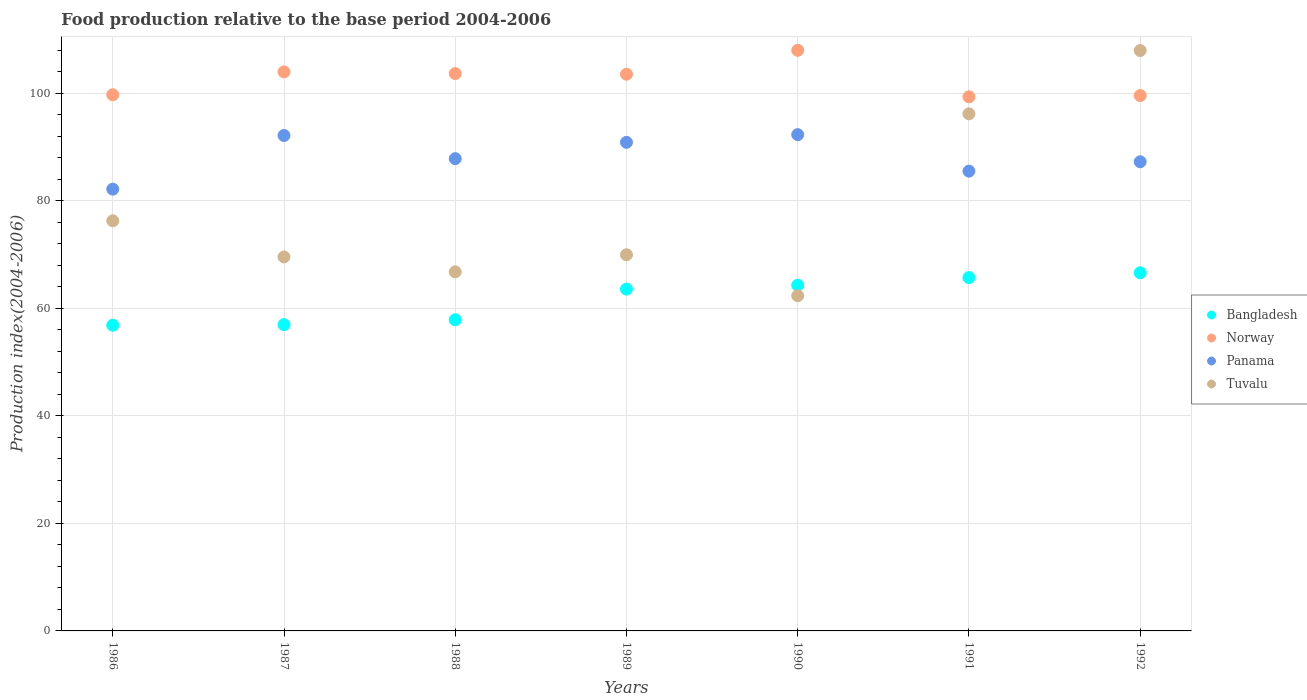How many different coloured dotlines are there?
Keep it short and to the point. 4. What is the food production index in Norway in 1992?
Make the answer very short. 99.54. Across all years, what is the maximum food production index in Tuvalu?
Your answer should be very brief. 107.91. Across all years, what is the minimum food production index in Panama?
Provide a succinct answer. 82.14. In which year was the food production index in Bangladesh minimum?
Offer a very short reply. 1986. What is the total food production index in Tuvalu in the graph?
Ensure brevity in your answer.  548.85. What is the difference between the food production index in Panama in 1988 and that in 1991?
Offer a very short reply. 2.32. What is the difference between the food production index in Panama in 1991 and the food production index in Norway in 1988?
Your answer should be very brief. -18.14. What is the average food production index in Bangladesh per year?
Ensure brevity in your answer.  61.68. In the year 1986, what is the difference between the food production index in Norway and food production index in Panama?
Your answer should be very brief. 17.55. What is the ratio of the food production index in Norway in 1990 to that in 1992?
Your answer should be compact. 1.08. What is the difference between the highest and the second highest food production index in Norway?
Provide a succinct answer. 4.01. What is the difference between the highest and the lowest food production index in Bangladesh?
Offer a very short reply. 9.75. In how many years, is the food production index in Panama greater than the average food production index in Panama taken over all years?
Offer a terse response. 3. Is the sum of the food production index in Bangladesh in 1987 and 1992 greater than the maximum food production index in Panama across all years?
Ensure brevity in your answer.  Yes. Is it the case that in every year, the sum of the food production index in Tuvalu and food production index in Panama  is greater than the sum of food production index in Norway and food production index in Bangladesh?
Keep it short and to the point. No. Is it the case that in every year, the sum of the food production index in Bangladesh and food production index in Norway  is greater than the food production index in Panama?
Provide a succinct answer. Yes. Is the food production index in Panama strictly greater than the food production index in Bangladesh over the years?
Provide a short and direct response. Yes. Is the food production index in Panama strictly less than the food production index in Tuvalu over the years?
Keep it short and to the point. No. How many dotlines are there?
Your answer should be very brief. 4. How many years are there in the graph?
Offer a very short reply. 7. Are the values on the major ticks of Y-axis written in scientific E-notation?
Your response must be concise. No. Does the graph contain grids?
Your response must be concise. Yes. Where does the legend appear in the graph?
Your answer should be very brief. Center right. How many legend labels are there?
Provide a succinct answer. 4. What is the title of the graph?
Offer a very short reply. Food production relative to the base period 2004-2006. What is the label or title of the X-axis?
Provide a succinct answer. Years. What is the label or title of the Y-axis?
Your answer should be very brief. Production index(2004-2006). What is the Production index(2004-2006) of Bangladesh in 1986?
Your answer should be compact. 56.84. What is the Production index(2004-2006) of Norway in 1986?
Offer a very short reply. 99.69. What is the Production index(2004-2006) of Panama in 1986?
Your answer should be compact. 82.14. What is the Production index(2004-2006) of Tuvalu in 1986?
Provide a succinct answer. 76.25. What is the Production index(2004-2006) of Bangladesh in 1987?
Your response must be concise. 56.95. What is the Production index(2004-2006) of Norway in 1987?
Keep it short and to the point. 103.94. What is the Production index(2004-2006) of Panama in 1987?
Provide a succinct answer. 92.11. What is the Production index(2004-2006) in Tuvalu in 1987?
Provide a short and direct response. 69.53. What is the Production index(2004-2006) of Bangladesh in 1988?
Offer a terse response. 57.85. What is the Production index(2004-2006) of Norway in 1988?
Give a very brief answer. 103.63. What is the Production index(2004-2006) of Panama in 1988?
Make the answer very short. 87.81. What is the Production index(2004-2006) in Tuvalu in 1988?
Offer a very short reply. 66.76. What is the Production index(2004-2006) of Bangladesh in 1989?
Make the answer very short. 63.55. What is the Production index(2004-2006) in Norway in 1989?
Offer a very short reply. 103.51. What is the Production index(2004-2006) in Panama in 1989?
Provide a succinct answer. 90.84. What is the Production index(2004-2006) of Tuvalu in 1989?
Your response must be concise. 69.94. What is the Production index(2004-2006) of Bangladesh in 1990?
Offer a very short reply. 64.28. What is the Production index(2004-2006) in Norway in 1990?
Provide a short and direct response. 107.95. What is the Production index(2004-2006) of Panama in 1990?
Ensure brevity in your answer.  92.27. What is the Production index(2004-2006) in Tuvalu in 1990?
Your answer should be compact. 62.32. What is the Production index(2004-2006) of Bangladesh in 1991?
Keep it short and to the point. 65.69. What is the Production index(2004-2006) in Norway in 1991?
Offer a very short reply. 99.31. What is the Production index(2004-2006) of Panama in 1991?
Offer a very short reply. 85.49. What is the Production index(2004-2006) of Tuvalu in 1991?
Your answer should be compact. 96.14. What is the Production index(2004-2006) in Bangladesh in 1992?
Your answer should be compact. 66.59. What is the Production index(2004-2006) in Norway in 1992?
Offer a very short reply. 99.54. What is the Production index(2004-2006) in Panama in 1992?
Provide a succinct answer. 87.23. What is the Production index(2004-2006) of Tuvalu in 1992?
Provide a succinct answer. 107.91. Across all years, what is the maximum Production index(2004-2006) of Bangladesh?
Make the answer very short. 66.59. Across all years, what is the maximum Production index(2004-2006) of Norway?
Make the answer very short. 107.95. Across all years, what is the maximum Production index(2004-2006) in Panama?
Provide a succinct answer. 92.27. Across all years, what is the maximum Production index(2004-2006) of Tuvalu?
Offer a very short reply. 107.91. Across all years, what is the minimum Production index(2004-2006) of Bangladesh?
Your response must be concise. 56.84. Across all years, what is the minimum Production index(2004-2006) of Norway?
Your answer should be compact. 99.31. Across all years, what is the minimum Production index(2004-2006) in Panama?
Ensure brevity in your answer.  82.14. Across all years, what is the minimum Production index(2004-2006) in Tuvalu?
Provide a succinct answer. 62.32. What is the total Production index(2004-2006) in Bangladesh in the graph?
Your answer should be compact. 431.75. What is the total Production index(2004-2006) in Norway in the graph?
Ensure brevity in your answer.  717.57. What is the total Production index(2004-2006) of Panama in the graph?
Offer a terse response. 617.89. What is the total Production index(2004-2006) of Tuvalu in the graph?
Provide a short and direct response. 548.85. What is the difference between the Production index(2004-2006) of Bangladesh in 1986 and that in 1987?
Offer a very short reply. -0.11. What is the difference between the Production index(2004-2006) of Norway in 1986 and that in 1987?
Make the answer very short. -4.25. What is the difference between the Production index(2004-2006) in Panama in 1986 and that in 1987?
Your answer should be compact. -9.97. What is the difference between the Production index(2004-2006) of Tuvalu in 1986 and that in 1987?
Keep it short and to the point. 6.72. What is the difference between the Production index(2004-2006) of Bangladesh in 1986 and that in 1988?
Offer a very short reply. -1.01. What is the difference between the Production index(2004-2006) in Norway in 1986 and that in 1988?
Your response must be concise. -3.94. What is the difference between the Production index(2004-2006) in Panama in 1986 and that in 1988?
Ensure brevity in your answer.  -5.67. What is the difference between the Production index(2004-2006) of Tuvalu in 1986 and that in 1988?
Provide a short and direct response. 9.49. What is the difference between the Production index(2004-2006) of Bangladesh in 1986 and that in 1989?
Your response must be concise. -6.71. What is the difference between the Production index(2004-2006) in Norway in 1986 and that in 1989?
Give a very brief answer. -3.82. What is the difference between the Production index(2004-2006) in Panama in 1986 and that in 1989?
Give a very brief answer. -8.7. What is the difference between the Production index(2004-2006) in Tuvalu in 1986 and that in 1989?
Your answer should be compact. 6.31. What is the difference between the Production index(2004-2006) in Bangladesh in 1986 and that in 1990?
Your answer should be compact. -7.44. What is the difference between the Production index(2004-2006) of Norway in 1986 and that in 1990?
Give a very brief answer. -8.26. What is the difference between the Production index(2004-2006) in Panama in 1986 and that in 1990?
Ensure brevity in your answer.  -10.13. What is the difference between the Production index(2004-2006) of Tuvalu in 1986 and that in 1990?
Your response must be concise. 13.93. What is the difference between the Production index(2004-2006) of Bangladesh in 1986 and that in 1991?
Give a very brief answer. -8.85. What is the difference between the Production index(2004-2006) in Norway in 1986 and that in 1991?
Offer a terse response. 0.38. What is the difference between the Production index(2004-2006) in Panama in 1986 and that in 1991?
Your answer should be very brief. -3.35. What is the difference between the Production index(2004-2006) of Tuvalu in 1986 and that in 1991?
Offer a very short reply. -19.89. What is the difference between the Production index(2004-2006) in Bangladesh in 1986 and that in 1992?
Provide a short and direct response. -9.75. What is the difference between the Production index(2004-2006) in Panama in 1986 and that in 1992?
Offer a terse response. -5.09. What is the difference between the Production index(2004-2006) in Tuvalu in 1986 and that in 1992?
Provide a short and direct response. -31.66. What is the difference between the Production index(2004-2006) in Norway in 1987 and that in 1988?
Give a very brief answer. 0.31. What is the difference between the Production index(2004-2006) in Tuvalu in 1987 and that in 1988?
Offer a very short reply. 2.77. What is the difference between the Production index(2004-2006) of Bangladesh in 1987 and that in 1989?
Make the answer very short. -6.6. What is the difference between the Production index(2004-2006) of Norway in 1987 and that in 1989?
Keep it short and to the point. 0.43. What is the difference between the Production index(2004-2006) in Panama in 1987 and that in 1989?
Keep it short and to the point. 1.27. What is the difference between the Production index(2004-2006) in Tuvalu in 1987 and that in 1989?
Offer a terse response. -0.41. What is the difference between the Production index(2004-2006) of Bangladesh in 1987 and that in 1990?
Provide a succinct answer. -7.33. What is the difference between the Production index(2004-2006) of Norway in 1987 and that in 1990?
Your answer should be compact. -4.01. What is the difference between the Production index(2004-2006) in Panama in 1987 and that in 1990?
Provide a succinct answer. -0.16. What is the difference between the Production index(2004-2006) of Tuvalu in 1987 and that in 1990?
Provide a succinct answer. 7.21. What is the difference between the Production index(2004-2006) of Bangladesh in 1987 and that in 1991?
Give a very brief answer. -8.74. What is the difference between the Production index(2004-2006) in Norway in 1987 and that in 1991?
Keep it short and to the point. 4.63. What is the difference between the Production index(2004-2006) in Panama in 1987 and that in 1991?
Your response must be concise. 6.62. What is the difference between the Production index(2004-2006) in Tuvalu in 1987 and that in 1991?
Offer a very short reply. -26.61. What is the difference between the Production index(2004-2006) in Bangladesh in 1987 and that in 1992?
Your answer should be very brief. -9.64. What is the difference between the Production index(2004-2006) in Panama in 1987 and that in 1992?
Your answer should be compact. 4.88. What is the difference between the Production index(2004-2006) of Tuvalu in 1987 and that in 1992?
Give a very brief answer. -38.38. What is the difference between the Production index(2004-2006) of Norway in 1988 and that in 1989?
Make the answer very short. 0.12. What is the difference between the Production index(2004-2006) in Panama in 1988 and that in 1989?
Offer a very short reply. -3.03. What is the difference between the Production index(2004-2006) of Tuvalu in 1988 and that in 1989?
Offer a very short reply. -3.18. What is the difference between the Production index(2004-2006) of Bangladesh in 1988 and that in 1990?
Your response must be concise. -6.43. What is the difference between the Production index(2004-2006) in Norway in 1988 and that in 1990?
Your answer should be compact. -4.32. What is the difference between the Production index(2004-2006) of Panama in 1988 and that in 1990?
Keep it short and to the point. -4.46. What is the difference between the Production index(2004-2006) of Tuvalu in 1988 and that in 1990?
Ensure brevity in your answer.  4.44. What is the difference between the Production index(2004-2006) in Bangladesh in 1988 and that in 1991?
Keep it short and to the point. -7.84. What is the difference between the Production index(2004-2006) of Norway in 1988 and that in 1991?
Ensure brevity in your answer.  4.32. What is the difference between the Production index(2004-2006) in Panama in 1988 and that in 1991?
Your response must be concise. 2.32. What is the difference between the Production index(2004-2006) in Tuvalu in 1988 and that in 1991?
Make the answer very short. -29.38. What is the difference between the Production index(2004-2006) in Bangladesh in 1988 and that in 1992?
Keep it short and to the point. -8.74. What is the difference between the Production index(2004-2006) of Norway in 1988 and that in 1992?
Ensure brevity in your answer.  4.09. What is the difference between the Production index(2004-2006) of Panama in 1988 and that in 1992?
Keep it short and to the point. 0.58. What is the difference between the Production index(2004-2006) of Tuvalu in 1988 and that in 1992?
Provide a succinct answer. -41.15. What is the difference between the Production index(2004-2006) in Bangladesh in 1989 and that in 1990?
Provide a succinct answer. -0.73. What is the difference between the Production index(2004-2006) of Norway in 1989 and that in 1990?
Provide a short and direct response. -4.44. What is the difference between the Production index(2004-2006) in Panama in 1989 and that in 1990?
Your answer should be compact. -1.43. What is the difference between the Production index(2004-2006) of Tuvalu in 1989 and that in 1990?
Your answer should be compact. 7.62. What is the difference between the Production index(2004-2006) in Bangladesh in 1989 and that in 1991?
Keep it short and to the point. -2.14. What is the difference between the Production index(2004-2006) in Panama in 1989 and that in 1991?
Your response must be concise. 5.35. What is the difference between the Production index(2004-2006) of Tuvalu in 1989 and that in 1991?
Your answer should be compact. -26.2. What is the difference between the Production index(2004-2006) in Bangladesh in 1989 and that in 1992?
Provide a short and direct response. -3.04. What is the difference between the Production index(2004-2006) of Norway in 1989 and that in 1992?
Make the answer very short. 3.97. What is the difference between the Production index(2004-2006) in Panama in 1989 and that in 1992?
Offer a terse response. 3.61. What is the difference between the Production index(2004-2006) in Tuvalu in 1989 and that in 1992?
Ensure brevity in your answer.  -37.97. What is the difference between the Production index(2004-2006) of Bangladesh in 1990 and that in 1991?
Offer a very short reply. -1.41. What is the difference between the Production index(2004-2006) in Norway in 1990 and that in 1991?
Your response must be concise. 8.64. What is the difference between the Production index(2004-2006) in Panama in 1990 and that in 1991?
Your answer should be very brief. 6.78. What is the difference between the Production index(2004-2006) in Tuvalu in 1990 and that in 1991?
Provide a short and direct response. -33.82. What is the difference between the Production index(2004-2006) in Bangladesh in 1990 and that in 1992?
Your response must be concise. -2.31. What is the difference between the Production index(2004-2006) in Norway in 1990 and that in 1992?
Provide a succinct answer. 8.41. What is the difference between the Production index(2004-2006) of Panama in 1990 and that in 1992?
Ensure brevity in your answer.  5.04. What is the difference between the Production index(2004-2006) in Tuvalu in 1990 and that in 1992?
Ensure brevity in your answer.  -45.59. What is the difference between the Production index(2004-2006) in Bangladesh in 1991 and that in 1992?
Your answer should be very brief. -0.9. What is the difference between the Production index(2004-2006) of Norway in 1991 and that in 1992?
Provide a succinct answer. -0.23. What is the difference between the Production index(2004-2006) of Panama in 1991 and that in 1992?
Make the answer very short. -1.74. What is the difference between the Production index(2004-2006) in Tuvalu in 1991 and that in 1992?
Offer a terse response. -11.77. What is the difference between the Production index(2004-2006) of Bangladesh in 1986 and the Production index(2004-2006) of Norway in 1987?
Your answer should be compact. -47.1. What is the difference between the Production index(2004-2006) in Bangladesh in 1986 and the Production index(2004-2006) in Panama in 1987?
Offer a very short reply. -35.27. What is the difference between the Production index(2004-2006) of Bangladesh in 1986 and the Production index(2004-2006) of Tuvalu in 1987?
Your answer should be very brief. -12.69. What is the difference between the Production index(2004-2006) in Norway in 1986 and the Production index(2004-2006) in Panama in 1987?
Your answer should be compact. 7.58. What is the difference between the Production index(2004-2006) of Norway in 1986 and the Production index(2004-2006) of Tuvalu in 1987?
Give a very brief answer. 30.16. What is the difference between the Production index(2004-2006) of Panama in 1986 and the Production index(2004-2006) of Tuvalu in 1987?
Provide a short and direct response. 12.61. What is the difference between the Production index(2004-2006) of Bangladesh in 1986 and the Production index(2004-2006) of Norway in 1988?
Keep it short and to the point. -46.79. What is the difference between the Production index(2004-2006) of Bangladesh in 1986 and the Production index(2004-2006) of Panama in 1988?
Your response must be concise. -30.97. What is the difference between the Production index(2004-2006) of Bangladesh in 1986 and the Production index(2004-2006) of Tuvalu in 1988?
Make the answer very short. -9.92. What is the difference between the Production index(2004-2006) in Norway in 1986 and the Production index(2004-2006) in Panama in 1988?
Ensure brevity in your answer.  11.88. What is the difference between the Production index(2004-2006) in Norway in 1986 and the Production index(2004-2006) in Tuvalu in 1988?
Your response must be concise. 32.93. What is the difference between the Production index(2004-2006) in Panama in 1986 and the Production index(2004-2006) in Tuvalu in 1988?
Offer a terse response. 15.38. What is the difference between the Production index(2004-2006) of Bangladesh in 1986 and the Production index(2004-2006) of Norway in 1989?
Give a very brief answer. -46.67. What is the difference between the Production index(2004-2006) in Bangladesh in 1986 and the Production index(2004-2006) in Panama in 1989?
Ensure brevity in your answer.  -34. What is the difference between the Production index(2004-2006) of Bangladesh in 1986 and the Production index(2004-2006) of Tuvalu in 1989?
Offer a terse response. -13.1. What is the difference between the Production index(2004-2006) in Norway in 1986 and the Production index(2004-2006) in Panama in 1989?
Make the answer very short. 8.85. What is the difference between the Production index(2004-2006) of Norway in 1986 and the Production index(2004-2006) of Tuvalu in 1989?
Your answer should be very brief. 29.75. What is the difference between the Production index(2004-2006) in Bangladesh in 1986 and the Production index(2004-2006) in Norway in 1990?
Your answer should be compact. -51.11. What is the difference between the Production index(2004-2006) of Bangladesh in 1986 and the Production index(2004-2006) of Panama in 1990?
Give a very brief answer. -35.43. What is the difference between the Production index(2004-2006) of Bangladesh in 1986 and the Production index(2004-2006) of Tuvalu in 1990?
Keep it short and to the point. -5.48. What is the difference between the Production index(2004-2006) of Norway in 1986 and the Production index(2004-2006) of Panama in 1990?
Offer a terse response. 7.42. What is the difference between the Production index(2004-2006) of Norway in 1986 and the Production index(2004-2006) of Tuvalu in 1990?
Make the answer very short. 37.37. What is the difference between the Production index(2004-2006) in Panama in 1986 and the Production index(2004-2006) in Tuvalu in 1990?
Give a very brief answer. 19.82. What is the difference between the Production index(2004-2006) in Bangladesh in 1986 and the Production index(2004-2006) in Norway in 1991?
Make the answer very short. -42.47. What is the difference between the Production index(2004-2006) of Bangladesh in 1986 and the Production index(2004-2006) of Panama in 1991?
Ensure brevity in your answer.  -28.65. What is the difference between the Production index(2004-2006) in Bangladesh in 1986 and the Production index(2004-2006) in Tuvalu in 1991?
Your answer should be compact. -39.3. What is the difference between the Production index(2004-2006) in Norway in 1986 and the Production index(2004-2006) in Tuvalu in 1991?
Provide a succinct answer. 3.55. What is the difference between the Production index(2004-2006) of Bangladesh in 1986 and the Production index(2004-2006) of Norway in 1992?
Give a very brief answer. -42.7. What is the difference between the Production index(2004-2006) in Bangladesh in 1986 and the Production index(2004-2006) in Panama in 1992?
Provide a short and direct response. -30.39. What is the difference between the Production index(2004-2006) in Bangladesh in 1986 and the Production index(2004-2006) in Tuvalu in 1992?
Provide a succinct answer. -51.07. What is the difference between the Production index(2004-2006) of Norway in 1986 and the Production index(2004-2006) of Panama in 1992?
Offer a terse response. 12.46. What is the difference between the Production index(2004-2006) in Norway in 1986 and the Production index(2004-2006) in Tuvalu in 1992?
Ensure brevity in your answer.  -8.22. What is the difference between the Production index(2004-2006) in Panama in 1986 and the Production index(2004-2006) in Tuvalu in 1992?
Keep it short and to the point. -25.77. What is the difference between the Production index(2004-2006) in Bangladesh in 1987 and the Production index(2004-2006) in Norway in 1988?
Offer a very short reply. -46.68. What is the difference between the Production index(2004-2006) of Bangladesh in 1987 and the Production index(2004-2006) of Panama in 1988?
Give a very brief answer. -30.86. What is the difference between the Production index(2004-2006) in Bangladesh in 1987 and the Production index(2004-2006) in Tuvalu in 1988?
Keep it short and to the point. -9.81. What is the difference between the Production index(2004-2006) in Norway in 1987 and the Production index(2004-2006) in Panama in 1988?
Offer a very short reply. 16.13. What is the difference between the Production index(2004-2006) of Norway in 1987 and the Production index(2004-2006) of Tuvalu in 1988?
Your answer should be very brief. 37.18. What is the difference between the Production index(2004-2006) of Panama in 1987 and the Production index(2004-2006) of Tuvalu in 1988?
Provide a short and direct response. 25.35. What is the difference between the Production index(2004-2006) of Bangladesh in 1987 and the Production index(2004-2006) of Norway in 1989?
Offer a terse response. -46.56. What is the difference between the Production index(2004-2006) in Bangladesh in 1987 and the Production index(2004-2006) in Panama in 1989?
Offer a very short reply. -33.89. What is the difference between the Production index(2004-2006) of Bangladesh in 1987 and the Production index(2004-2006) of Tuvalu in 1989?
Make the answer very short. -12.99. What is the difference between the Production index(2004-2006) in Norway in 1987 and the Production index(2004-2006) in Tuvalu in 1989?
Keep it short and to the point. 34. What is the difference between the Production index(2004-2006) in Panama in 1987 and the Production index(2004-2006) in Tuvalu in 1989?
Give a very brief answer. 22.17. What is the difference between the Production index(2004-2006) in Bangladesh in 1987 and the Production index(2004-2006) in Norway in 1990?
Keep it short and to the point. -51. What is the difference between the Production index(2004-2006) of Bangladesh in 1987 and the Production index(2004-2006) of Panama in 1990?
Give a very brief answer. -35.32. What is the difference between the Production index(2004-2006) of Bangladesh in 1987 and the Production index(2004-2006) of Tuvalu in 1990?
Keep it short and to the point. -5.37. What is the difference between the Production index(2004-2006) in Norway in 1987 and the Production index(2004-2006) in Panama in 1990?
Provide a succinct answer. 11.67. What is the difference between the Production index(2004-2006) of Norway in 1987 and the Production index(2004-2006) of Tuvalu in 1990?
Your response must be concise. 41.62. What is the difference between the Production index(2004-2006) of Panama in 1987 and the Production index(2004-2006) of Tuvalu in 1990?
Keep it short and to the point. 29.79. What is the difference between the Production index(2004-2006) of Bangladesh in 1987 and the Production index(2004-2006) of Norway in 1991?
Ensure brevity in your answer.  -42.36. What is the difference between the Production index(2004-2006) in Bangladesh in 1987 and the Production index(2004-2006) in Panama in 1991?
Your response must be concise. -28.54. What is the difference between the Production index(2004-2006) in Bangladesh in 1987 and the Production index(2004-2006) in Tuvalu in 1991?
Your answer should be very brief. -39.19. What is the difference between the Production index(2004-2006) of Norway in 1987 and the Production index(2004-2006) of Panama in 1991?
Your response must be concise. 18.45. What is the difference between the Production index(2004-2006) of Norway in 1987 and the Production index(2004-2006) of Tuvalu in 1991?
Your answer should be compact. 7.8. What is the difference between the Production index(2004-2006) in Panama in 1987 and the Production index(2004-2006) in Tuvalu in 1991?
Provide a succinct answer. -4.03. What is the difference between the Production index(2004-2006) in Bangladesh in 1987 and the Production index(2004-2006) in Norway in 1992?
Your answer should be very brief. -42.59. What is the difference between the Production index(2004-2006) of Bangladesh in 1987 and the Production index(2004-2006) of Panama in 1992?
Your answer should be compact. -30.28. What is the difference between the Production index(2004-2006) in Bangladesh in 1987 and the Production index(2004-2006) in Tuvalu in 1992?
Ensure brevity in your answer.  -50.96. What is the difference between the Production index(2004-2006) of Norway in 1987 and the Production index(2004-2006) of Panama in 1992?
Provide a short and direct response. 16.71. What is the difference between the Production index(2004-2006) in Norway in 1987 and the Production index(2004-2006) in Tuvalu in 1992?
Your answer should be very brief. -3.97. What is the difference between the Production index(2004-2006) in Panama in 1987 and the Production index(2004-2006) in Tuvalu in 1992?
Provide a succinct answer. -15.8. What is the difference between the Production index(2004-2006) of Bangladesh in 1988 and the Production index(2004-2006) of Norway in 1989?
Ensure brevity in your answer.  -45.66. What is the difference between the Production index(2004-2006) of Bangladesh in 1988 and the Production index(2004-2006) of Panama in 1989?
Provide a short and direct response. -32.99. What is the difference between the Production index(2004-2006) in Bangladesh in 1988 and the Production index(2004-2006) in Tuvalu in 1989?
Ensure brevity in your answer.  -12.09. What is the difference between the Production index(2004-2006) in Norway in 1988 and the Production index(2004-2006) in Panama in 1989?
Ensure brevity in your answer.  12.79. What is the difference between the Production index(2004-2006) of Norway in 1988 and the Production index(2004-2006) of Tuvalu in 1989?
Keep it short and to the point. 33.69. What is the difference between the Production index(2004-2006) of Panama in 1988 and the Production index(2004-2006) of Tuvalu in 1989?
Your answer should be compact. 17.87. What is the difference between the Production index(2004-2006) of Bangladesh in 1988 and the Production index(2004-2006) of Norway in 1990?
Provide a succinct answer. -50.1. What is the difference between the Production index(2004-2006) of Bangladesh in 1988 and the Production index(2004-2006) of Panama in 1990?
Your answer should be compact. -34.42. What is the difference between the Production index(2004-2006) in Bangladesh in 1988 and the Production index(2004-2006) in Tuvalu in 1990?
Make the answer very short. -4.47. What is the difference between the Production index(2004-2006) in Norway in 1988 and the Production index(2004-2006) in Panama in 1990?
Provide a short and direct response. 11.36. What is the difference between the Production index(2004-2006) in Norway in 1988 and the Production index(2004-2006) in Tuvalu in 1990?
Your answer should be compact. 41.31. What is the difference between the Production index(2004-2006) of Panama in 1988 and the Production index(2004-2006) of Tuvalu in 1990?
Your response must be concise. 25.49. What is the difference between the Production index(2004-2006) in Bangladesh in 1988 and the Production index(2004-2006) in Norway in 1991?
Offer a very short reply. -41.46. What is the difference between the Production index(2004-2006) in Bangladesh in 1988 and the Production index(2004-2006) in Panama in 1991?
Provide a short and direct response. -27.64. What is the difference between the Production index(2004-2006) of Bangladesh in 1988 and the Production index(2004-2006) of Tuvalu in 1991?
Provide a short and direct response. -38.29. What is the difference between the Production index(2004-2006) of Norway in 1988 and the Production index(2004-2006) of Panama in 1991?
Give a very brief answer. 18.14. What is the difference between the Production index(2004-2006) of Norway in 1988 and the Production index(2004-2006) of Tuvalu in 1991?
Your answer should be very brief. 7.49. What is the difference between the Production index(2004-2006) in Panama in 1988 and the Production index(2004-2006) in Tuvalu in 1991?
Provide a succinct answer. -8.33. What is the difference between the Production index(2004-2006) in Bangladesh in 1988 and the Production index(2004-2006) in Norway in 1992?
Give a very brief answer. -41.69. What is the difference between the Production index(2004-2006) of Bangladesh in 1988 and the Production index(2004-2006) of Panama in 1992?
Keep it short and to the point. -29.38. What is the difference between the Production index(2004-2006) of Bangladesh in 1988 and the Production index(2004-2006) of Tuvalu in 1992?
Provide a short and direct response. -50.06. What is the difference between the Production index(2004-2006) in Norway in 1988 and the Production index(2004-2006) in Panama in 1992?
Make the answer very short. 16.4. What is the difference between the Production index(2004-2006) of Norway in 1988 and the Production index(2004-2006) of Tuvalu in 1992?
Give a very brief answer. -4.28. What is the difference between the Production index(2004-2006) in Panama in 1988 and the Production index(2004-2006) in Tuvalu in 1992?
Your response must be concise. -20.1. What is the difference between the Production index(2004-2006) in Bangladesh in 1989 and the Production index(2004-2006) in Norway in 1990?
Your response must be concise. -44.4. What is the difference between the Production index(2004-2006) of Bangladesh in 1989 and the Production index(2004-2006) of Panama in 1990?
Your response must be concise. -28.72. What is the difference between the Production index(2004-2006) in Bangladesh in 1989 and the Production index(2004-2006) in Tuvalu in 1990?
Give a very brief answer. 1.23. What is the difference between the Production index(2004-2006) in Norway in 1989 and the Production index(2004-2006) in Panama in 1990?
Your response must be concise. 11.24. What is the difference between the Production index(2004-2006) of Norway in 1989 and the Production index(2004-2006) of Tuvalu in 1990?
Offer a terse response. 41.19. What is the difference between the Production index(2004-2006) of Panama in 1989 and the Production index(2004-2006) of Tuvalu in 1990?
Provide a succinct answer. 28.52. What is the difference between the Production index(2004-2006) in Bangladesh in 1989 and the Production index(2004-2006) in Norway in 1991?
Make the answer very short. -35.76. What is the difference between the Production index(2004-2006) in Bangladesh in 1989 and the Production index(2004-2006) in Panama in 1991?
Make the answer very short. -21.94. What is the difference between the Production index(2004-2006) of Bangladesh in 1989 and the Production index(2004-2006) of Tuvalu in 1991?
Provide a succinct answer. -32.59. What is the difference between the Production index(2004-2006) in Norway in 1989 and the Production index(2004-2006) in Panama in 1991?
Your answer should be compact. 18.02. What is the difference between the Production index(2004-2006) of Norway in 1989 and the Production index(2004-2006) of Tuvalu in 1991?
Provide a succinct answer. 7.37. What is the difference between the Production index(2004-2006) of Panama in 1989 and the Production index(2004-2006) of Tuvalu in 1991?
Your response must be concise. -5.3. What is the difference between the Production index(2004-2006) in Bangladesh in 1989 and the Production index(2004-2006) in Norway in 1992?
Keep it short and to the point. -35.99. What is the difference between the Production index(2004-2006) of Bangladesh in 1989 and the Production index(2004-2006) of Panama in 1992?
Your answer should be compact. -23.68. What is the difference between the Production index(2004-2006) in Bangladesh in 1989 and the Production index(2004-2006) in Tuvalu in 1992?
Offer a very short reply. -44.36. What is the difference between the Production index(2004-2006) of Norway in 1989 and the Production index(2004-2006) of Panama in 1992?
Ensure brevity in your answer.  16.28. What is the difference between the Production index(2004-2006) in Panama in 1989 and the Production index(2004-2006) in Tuvalu in 1992?
Offer a very short reply. -17.07. What is the difference between the Production index(2004-2006) of Bangladesh in 1990 and the Production index(2004-2006) of Norway in 1991?
Provide a succinct answer. -35.03. What is the difference between the Production index(2004-2006) in Bangladesh in 1990 and the Production index(2004-2006) in Panama in 1991?
Your answer should be very brief. -21.21. What is the difference between the Production index(2004-2006) in Bangladesh in 1990 and the Production index(2004-2006) in Tuvalu in 1991?
Ensure brevity in your answer.  -31.86. What is the difference between the Production index(2004-2006) of Norway in 1990 and the Production index(2004-2006) of Panama in 1991?
Provide a succinct answer. 22.46. What is the difference between the Production index(2004-2006) of Norway in 1990 and the Production index(2004-2006) of Tuvalu in 1991?
Your answer should be compact. 11.81. What is the difference between the Production index(2004-2006) in Panama in 1990 and the Production index(2004-2006) in Tuvalu in 1991?
Ensure brevity in your answer.  -3.87. What is the difference between the Production index(2004-2006) of Bangladesh in 1990 and the Production index(2004-2006) of Norway in 1992?
Make the answer very short. -35.26. What is the difference between the Production index(2004-2006) of Bangladesh in 1990 and the Production index(2004-2006) of Panama in 1992?
Make the answer very short. -22.95. What is the difference between the Production index(2004-2006) in Bangladesh in 1990 and the Production index(2004-2006) in Tuvalu in 1992?
Offer a very short reply. -43.63. What is the difference between the Production index(2004-2006) in Norway in 1990 and the Production index(2004-2006) in Panama in 1992?
Keep it short and to the point. 20.72. What is the difference between the Production index(2004-2006) of Panama in 1990 and the Production index(2004-2006) of Tuvalu in 1992?
Make the answer very short. -15.64. What is the difference between the Production index(2004-2006) in Bangladesh in 1991 and the Production index(2004-2006) in Norway in 1992?
Provide a succinct answer. -33.85. What is the difference between the Production index(2004-2006) in Bangladesh in 1991 and the Production index(2004-2006) in Panama in 1992?
Give a very brief answer. -21.54. What is the difference between the Production index(2004-2006) in Bangladesh in 1991 and the Production index(2004-2006) in Tuvalu in 1992?
Provide a short and direct response. -42.22. What is the difference between the Production index(2004-2006) in Norway in 1991 and the Production index(2004-2006) in Panama in 1992?
Ensure brevity in your answer.  12.08. What is the difference between the Production index(2004-2006) in Panama in 1991 and the Production index(2004-2006) in Tuvalu in 1992?
Provide a succinct answer. -22.42. What is the average Production index(2004-2006) of Bangladesh per year?
Your response must be concise. 61.68. What is the average Production index(2004-2006) in Norway per year?
Your answer should be very brief. 102.51. What is the average Production index(2004-2006) in Panama per year?
Offer a terse response. 88.27. What is the average Production index(2004-2006) in Tuvalu per year?
Provide a succinct answer. 78.41. In the year 1986, what is the difference between the Production index(2004-2006) of Bangladesh and Production index(2004-2006) of Norway?
Provide a succinct answer. -42.85. In the year 1986, what is the difference between the Production index(2004-2006) in Bangladesh and Production index(2004-2006) in Panama?
Your answer should be compact. -25.3. In the year 1986, what is the difference between the Production index(2004-2006) of Bangladesh and Production index(2004-2006) of Tuvalu?
Keep it short and to the point. -19.41. In the year 1986, what is the difference between the Production index(2004-2006) in Norway and Production index(2004-2006) in Panama?
Make the answer very short. 17.55. In the year 1986, what is the difference between the Production index(2004-2006) in Norway and Production index(2004-2006) in Tuvalu?
Ensure brevity in your answer.  23.44. In the year 1986, what is the difference between the Production index(2004-2006) in Panama and Production index(2004-2006) in Tuvalu?
Provide a short and direct response. 5.89. In the year 1987, what is the difference between the Production index(2004-2006) of Bangladesh and Production index(2004-2006) of Norway?
Ensure brevity in your answer.  -46.99. In the year 1987, what is the difference between the Production index(2004-2006) in Bangladesh and Production index(2004-2006) in Panama?
Provide a succinct answer. -35.16. In the year 1987, what is the difference between the Production index(2004-2006) in Bangladesh and Production index(2004-2006) in Tuvalu?
Your answer should be very brief. -12.58. In the year 1987, what is the difference between the Production index(2004-2006) of Norway and Production index(2004-2006) of Panama?
Keep it short and to the point. 11.83. In the year 1987, what is the difference between the Production index(2004-2006) of Norway and Production index(2004-2006) of Tuvalu?
Offer a terse response. 34.41. In the year 1987, what is the difference between the Production index(2004-2006) of Panama and Production index(2004-2006) of Tuvalu?
Provide a short and direct response. 22.58. In the year 1988, what is the difference between the Production index(2004-2006) of Bangladesh and Production index(2004-2006) of Norway?
Ensure brevity in your answer.  -45.78. In the year 1988, what is the difference between the Production index(2004-2006) of Bangladesh and Production index(2004-2006) of Panama?
Make the answer very short. -29.96. In the year 1988, what is the difference between the Production index(2004-2006) in Bangladesh and Production index(2004-2006) in Tuvalu?
Keep it short and to the point. -8.91. In the year 1988, what is the difference between the Production index(2004-2006) in Norway and Production index(2004-2006) in Panama?
Make the answer very short. 15.82. In the year 1988, what is the difference between the Production index(2004-2006) in Norway and Production index(2004-2006) in Tuvalu?
Provide a short and direct response. 36.87. In the year 1988, what is the difference between the Production index(2004-2006) in Panama and Production index(2004-2006) in Tuvalu?
Provide a succinct answer. 21.05. In the year 1989, what is the difference between the Production index(2004-2006) of Bangladesh and Production index(2004-2006) of Norway?
Keep it short and to the point. -39.96. In the year 1989, what is the difference between the Production index(2004-2006) of Bangladesh and Production index(2004-2006) of Panama?
Your response must be concise. -27.29. In the year 1989, what is the difference between the Production index(2004-2006) of Bangladesh and Production index(2004-2006) of Tuvalu?
Ensure brevity in your answer.  -6.39. In the year 1989, what is the difference between the Production index(2004-2006) of Norway and Production index(2004-2006) of Panama?
Offer a very short reply. 12.67. In the year 1989, what is the difference between the Production index(2004-2006) in Norway and Production index(2004-2006) in Tuvalu?
Provide a short and direct response. 33.57. In the year 1989, what is the difference between the Production index(2004-2006) of Panama and Production index(2004-2006) of Tuvalu?
Provide a succinct answer. 20.9. In the year 1990, what is the difference between the Production index(2004-2006) in Bangladesh and Production index(2004-2006) in Norway?
Keep it short and to the point. -43.67. In the year 1990, what is the difference between the Production index(2004-2006) of Bangladesh and Production index(2004-2006) of Panama?
Your answer should be very brief. -27.99. In the year 1990, what is the difference between the Production index(2004-2006) in Bangladesh and Production index(2004-2006) in Tuvalu?
Provide a short and direct response. 1.96. In the year 1990, what is the difference between the Production index(2004-2006) in Norway and Production index(2004-2006) in Panama?
Make the answer very short. 15.68. In the year 1990, what is the difference between the Production index(2004-2006) in Norway and Production index(2004-2006) in Tuvalu?
Provide a short and direct response. 45.63. In the year 1990, what is the difference between the Production index(2004-2006) in Panama and Production index(2004-2006) in Tuvalu?
Offer a very short reply. 29.95. In the year 1991, what is the difference between the Production index(2004-2006) of Bangladesh and Production index(2004-2006) of Norway?
Keep it short and to the point. -33.62. In the year 1991, what is the difference between the Production index(2004-2006) in Bangladesh and Production index(2004-2006) in Panama?
Ensure brevity in your answer.  -19.8. In the year 1991, what is the difference between the Production index(2004-2006) of Bangladesh and Production index(2004-2006) of Tuvalu?
Your response must be concise. -30.45. In the year 1991, what is the difference between the Production index(2004-2006) in Norway and Production index(2004-2006) in Panama?
Keep it short and to the point. 13.82. In the year 1991, what is the difference between the Production index(2004-2006) in Norway and Production index(2004-2006) in Tuvalu?
Provide a short and direct response. 3.17. In the year 1991, what is the difference between the Production index(2004-2006) in Panama and Production index(2004-2006) in Tuvalu?
Ensure brevity in your answer.  -10.65. In the year 1992, what is the difference between the Production index(2004-2006) in Bangladesh and Production index(2004-2006) in Norway?
Offer a very short reply. -32.95. In the year 1992, what is the difference between the Production index(2004-2006) in Bangladesh and Production index(2004-2006) in Panama?
Make the answer very short. -20.64. In the year 1992, what is the difference between the Production index(2004-2006) of Bangladesh and Production index(2004-2006) of Tuvalu?
Provide a short and direct response. -41.32. In the year 1992, what is the difference between the Production index(2004-2006) in Norway and Production index(2004-2006) in Panama?
Ensure brevity in your answer.  12.31. In the year 1992, what is the difference between the Production index(2004-2006) in Norway and Production index(2004-2006) in Tuvalu?
Ensure brevity in your answer.  -8.37. In the year 1992, what is the difference between the Production index(2004-2006) in Panama and Production index(2004-2006) in Tuvalu?
Offer a very short reply. -20.68. What is the ratio of the Production index(2004-2006) in Norway in 1986 to that in 1987?
Your response must be concise. 0.96. What is the ratio of the Production index(2004-2006) of Panama in 1986 to that in 1987?
Give a very brief answer. 0.89. What is the ratio of the Production index(2004-2006) in Tuvalu in 1986 to that in 1987?
Ensure brevity in your answer.  1.1. What is the ratio of the Production index(2004-2006) in Bangladesh in 1986 to that in 1988?
Provide a short and direct response. 0.98. What is the ratio of the Production index(2004-2006) in Panama in 1986 to that in 1988?
Offer a very short reply. 0.94. What is the ratio of the Production index(2004-2006) in Tuvalu in 1986 to that in 1988?
Keep it short and to the point. 1.14. What is the ratio of the Production index(2004-2006) in Bangladesh in 1986 to that in 1989?
Keep it short and to the point. 0.89. What is the ratio of the Production index(2004-2006) in Norway in 1986 to that in 1989?
Your answer should be very brief. 0.96. What is the ratio of the Production index(2004-2006) in Panama in 1986 to that in 1989?
Make the answer very short. 0.9. What is the ratio of the Production index(2004-2006) of Tuvalu in 1986 to that in 1989?
Offer a very short reply. 1.09. What is the ratio of the Production index(2004-2006) of Bangladesh in 1986 to that in 1990?
Ensure brevity in your answer.  0.88. What is the ratio of the Production index(2004-2006) in Norway in 1986 to that in 1990?
Your answer should be compact. 0.92. What is the ratio of the Production index(2004-2006) in Panama in 1986 to that in 1990?
Ensure brevity in your answer.  0.89. What is the ratio of the Production index(2004-2006) in Tuvalu in 1986 to that in 1990?
Give a very brief answer. 1.22. What is the ratio of the Production index(2004-2006) in Bangladesh in 1986 to that in 1991?
Give a very brief answer. 0.87. What is the ratio of the Production index(2004-2006) of Panama in 1986 to that in 1991?
Make the answer very short. 0.96. What is the ratio of the Production index(2004-2006) in Tuvalu in 1986 to that in 1991?
Your response must be concise. 0.79. What is the ratio of the Production index(2004-2006) of Bangladesh in 1986 to that in 1992?
Ensure brevity in your answer.  0.85. What is the ratio of the Production index(2004-2006) in Panama in 1986 to that in 1992?
Give a very brief answer. 0.94. What is the ratio of the Production index(2004-2006) in Tuvalu in 1986 to that in 1992?
Make the answer very short. 0.71. What is the ratio of the Production index(2004-2006) in Bangladesh in 1987 to that in 1988?
Your answer should be very brief. 0.98. What is the ratio of the Production index(2004-2006) of Norway in 1987 to that in 1988?
Ensure brevity in your answer.  1. What is the ratio of the Production index(2004-2006) of Panama in 1987 to that in 1988?
Provide a short and direct response. 1.05. What is the ratio of the Production index(2004-2006) of Tuvalu in 1987 to that in 1988?
Provide a short and direct response. 1.04. What is the ratio of the Production index(2004-2006) in Bangladesh in 1987 to that in 1989?
Your answer should be compact. 0.9. What is the ratio of the Production index(2004-2006) of Panama in 1987 to that in 1989?
Your answer should be compact. 1.01. What is the ratio of the Production index(2004-2006) in Tuvalu in 1987 to that in 1989?
Give a very brief answer. 0.99. What is the ratio of the Production index(2004-2006) in Bangladesh in 1987 to that in 1990?
Provide a short and direct response. 0.89. What is the ratio of the Production index(2004-2006) of Norway in 1987 to that in 1990?
Make the answer very short. 0.96. What is the ratio of the Production index(2004-2006) in Tuvalu in 1987 to that in 1990?
Your answer should be compact. 1.12. What is the ratio of the Production index(2004-2006) in Bangladesh in 1987 to that in 1991?
Keep it short and to the point. 0.87. What is the ratio of the Production index(2004-2006) in Norway in 1987 to that in 1991?
Make the answer very short. 1.05. What is the ratio of the Production index(2004-2006) in Panama in 1987 to that in 1991?
Give a very brief answer. 1.08. What is the ratio of the Production index(2004-2006) in Tuvalu in 1987 to that in 1991?
Provide a succinct answer. 0.72. What is the ratio of the Production index(2004-2006) in Bangladesh in 1987 to that in 1992?
Keep it short and to the point. 0.86. What is the ratio of the Production index(2004-2006) of Norway in 1987 to that in 1992?
Provide a short and direct response. 1.04. What is the ratio of the Production index(2004-2006) in Panama in 1987 to that in 1992?
Keep it short and to the point. 1.06. What is the ratio of the Production index(2004-2006) of Tuvalu in 1987 to that in 1992?
Provide a short and direct response. 0.64. What is the ratio of the Production index(2004-2006) of Bangladesh in 1988 to that in 1989?
Your answer should be very brief. 0.91. What is the ratio of the Production index(2004-2006) in Norway in 1988 to that in 1989?
Offer a very short reply. 1. What is the ratio of the Production index(2004-2006) of Panama in 1988 to that in 1989?
Your answer should be compact. 0.97. What is the ratio of the Production index(2004-2006) of Tuvalu in 1988 to that in 1989?
Ensure brevity in your answer.  0.95. What is the ratio of the Production index(2004-2006) of Norway in 1988 to that in 1990?
Offer a terse response. 0.96. What is the ratio of the Production index(2004-2006) of Panama in 1988 to that in 1990?
Ensure brevity in your answer.  0.95. What is the ratio of the Production index(2004-2006) in Tuvalu in 1988 to that in 1990?
Offer a very short reply. 1.07. What is the ratio of the Production index(2004-2006) of Bangladesh in 1988 to that in 1991?
Provide a succinct answer. 0.88. What is the ratio of the Production index(2004-2006) of Norway in 1988 to that in 1991?
Keep it short and to the point. 1.04. What is the ratio of the Production index(2004-2006) of Panama in 1988 to that in 1991?
Your answer should be compact. 1.03. What is the ratio of the Production index(2004-2006) of Tuvalu in 1988 to that in 1991?
Offer a terse response. 0.69. What is the ratio of the Production index(2004-2006) of Bangladesh in 1988 to that in 1992?
Ensure brevity in your answer.  0.87. What is the ratio of the Production index(2004-2006) in Norway in 1988 to that in 1992?
Keep it short and to the point. 1.04. What is the ratio of the Production index(2004-2006) in Panama in 1988 to that in 1992?
Offer a very short reply. 1.01. What is the ratio of the Production index(2004-2006) in Tuvalu in 1988 to that in 1992?
Your answer should be very brief. 0.62. What is the ratio of the Production index(2004-2006) in Norway in 1989 to that in 1990?
Your answer should be very brief. 0.96. What is the ratio of the Production index(2004-2006) in Panama in 1989 to that in 1990?
Offer a terse response. 0.98. What is the ratio of the Production index(2004-2006) of Tuvalu in 1989 to that in 1990?
Make the answer very short. 1.12. What is the ratio of the Production index(2004-2006) in Bangladesh in 1989 to that in 1991?
Make the answer very short. 0.97. What is the ratio of the Production index(2004-2006) in Norway in 1989 to that in 1991?
Make the answer very short. 1.04. What is the ratio of the Production index(2004-2006) of Panama in 1989 to that in 1991?
Your response must be concise. 1.06. What is the ratio of the Production index(2004-2006) of Tuvalu in 1989 to that in 1991?
Give a very brief answer. 0.73. What is the ratio of the Production index(2004-2006) in Bangladesh in 1989 to that in 1992?
Offer a terse response. 0.95. What is the ratio of the Production index(2004-2006) in Norway in 1989 to that in 1992?
Offer a very short reply. 1.04. What is the ratio of the Production index(2004-2006) in Panama in 1989 to that in 1992?
Ensure brevity in your answer.  1.04. What is the ratio of the Production index(2004-2006) in Tuvalu in 1989 to that in 1992?
Offer a very short reply. 0.65. What is the ratio of the Production index(2004-2006) of Bangladesh in 1990 to that in 1991?
Provide a succinct answer. 0.98. What is the ratio of the Production index(2004-2006) of Norway in 1990 to that in 1991?
Ensure brevity in your answer.  1.09. What is the ratio of the Production index(2004-2006) of Panama in 1990 to that in 1991?
Your response must be concise. 1.08. What is the ratio of the Production index(2004-2006) in Tuvalu in 1990 to that in 1991?
Your response must be concise. 0.65. What is the ratio of the Production index(2004-2006) in Bangladesh in 1990 to that in 1992?
Offer a terse response. 0.97. What is the ratio of the Production index(2004-2006) of Norway in 1990 to that in 1992?
Provide a short and direct response. 1.08. What is the ratio of the Production index(2004-2006) in Panama in 1990 to that in 1992?
Your answer should be compact. 1.06. What is the ratio of the Production index(2004-2006) in Tuvalu in 1990 to that in 1992?
Offer a terse response. 0.58. What is the ratio of the Production index(2004-2006) in Bangladesh in 1991 to that in 1992?
Ensure brevity in your answer.  0.99. What is the ratio of the Production index(2004-2006) in Panama in 1991 to that in 1992?
Your answer should be compact. 0.98. What is the ratio of the Production index(2004-2006) in Tuvalu in 1991 to that in 1992?
Offer a terse response. 0.89. What is the difference between the highest and the second highest Production index(2004-2006) in Bangladesh?
Your response must be concise. 0.9. What is the difference between the highest and the second highest Production index(2004-2006) in Norway?
Offer a very short reply. 4.01. What is the difference between the highest and the second highest Production index(2004-2006) in Panama?
Offer a very short reply. 0.16. What is the difference between the highest and the second highest Production index(2004-2006) of Tuvalu?
Provide a short and direct response. 11.77. What is the difference between the highest and the lowest Production index(2004-2006) in Bangladesh?
Offer a very short reply. 9.75. What is the difference between the highest and the lowest Production index(2004-2006) of Norway?
Provide a short and direct response. 8.64. What is the difference between the highest and the lowest Production index(2004-2006) of Panama?
Provide a short and direct response. 10.13. What is the difference between the highest and the lowest Production index(2004-2006) in Tuvalu?
Ensure brevity in your answer.  45.59. 